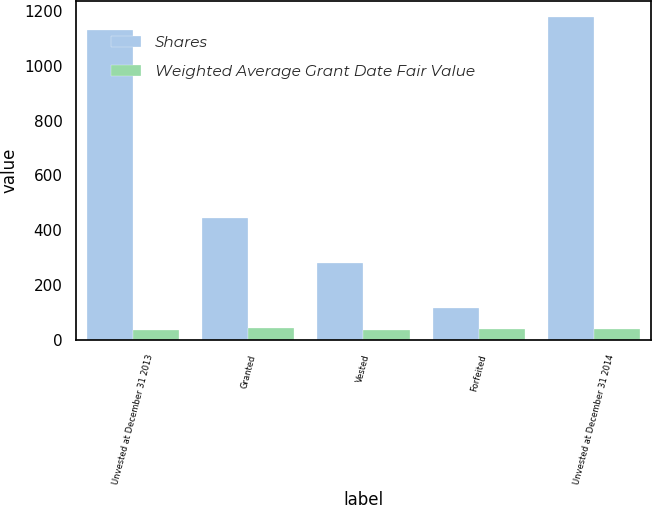Convert chart. <chart><loc_0><loc_0><loc_500><loc_500><stacked_bar_chart><ecel><fcel>Unvested at December 31 2013<fcel>Granted<fcel>Vested<fcel>Forfeited<fcel>Unvested at December 31 2014<nl><fcel>Shares<fcel>1131<fcel>447<fcel>282<fcel>119<fcel>1177<nl><fcel>Weighted Average Grant Date Fair Value<fcel>38.81<fcel>45.2<fcel>36.6<fcel>40.9<fcel>41.55<nl></chart> 